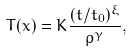<formula> <loc_0><loc_0><loc_500><loc_500>T ( x ) = K \frac { ( t / t _ { 0 } ) ^ { \xi } } { \rho ^ { \gamma } } ,</formula> 